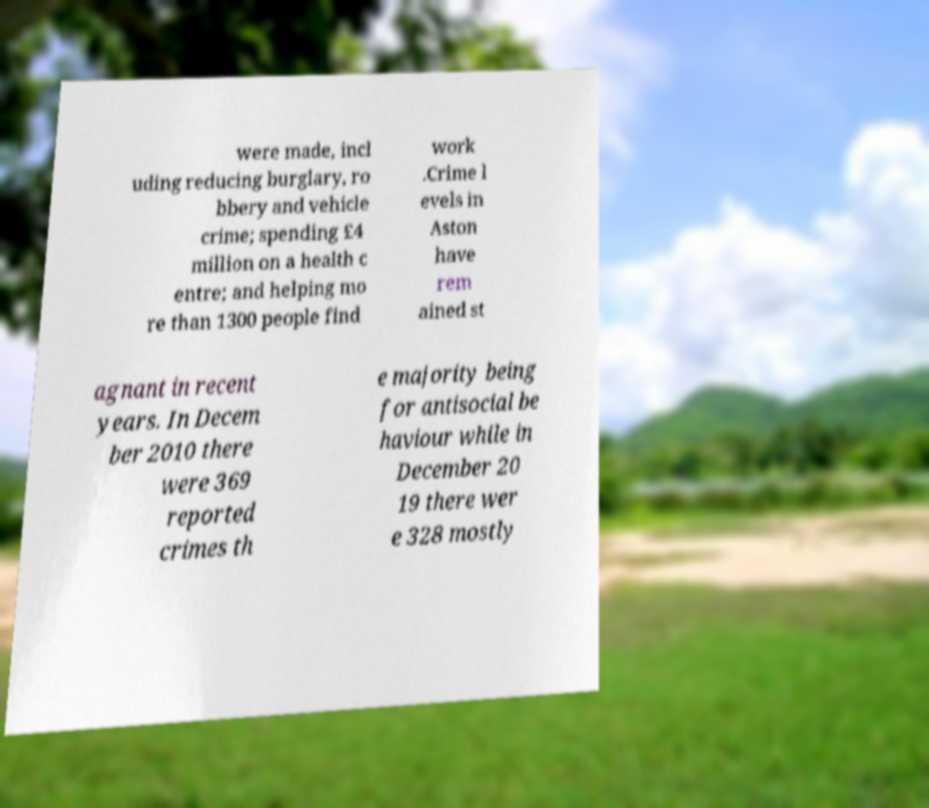Could you assist in decoding the text presented in this image and type it out clearly? were made, incl uding reducing burglary, ro bbery and vehicle crime; spending £4 million on a health c entre; and helping mo re than 1300 people find work .Crime l evels in Aston have rem ained st agnant in recent years. In Decem ber 2010 there were 369 reported crimes th e majority being for antisocial be haviour while in December 20 19 there wer e 328 mostly 